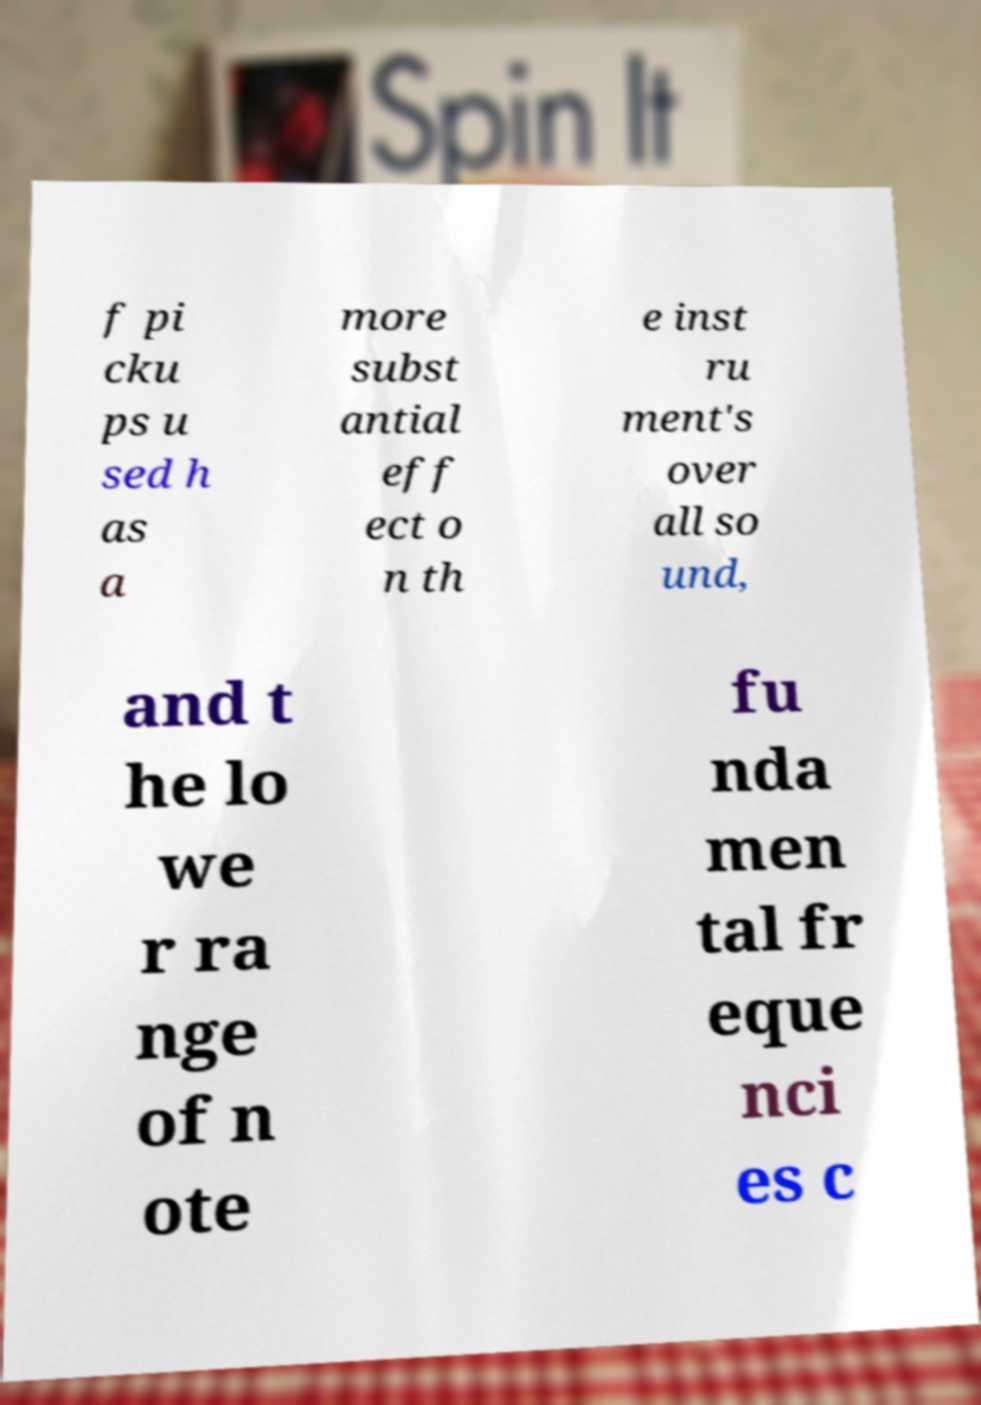There's text embedded in this image that I need extracted. Can you transcribe it verbatim? f pi cku ps u sed h as a more subst antial eff ect o n th e inst ru ment's over all so und, and t he lo we r ra nge of n ote fu nda men tal fr eque nci es c 